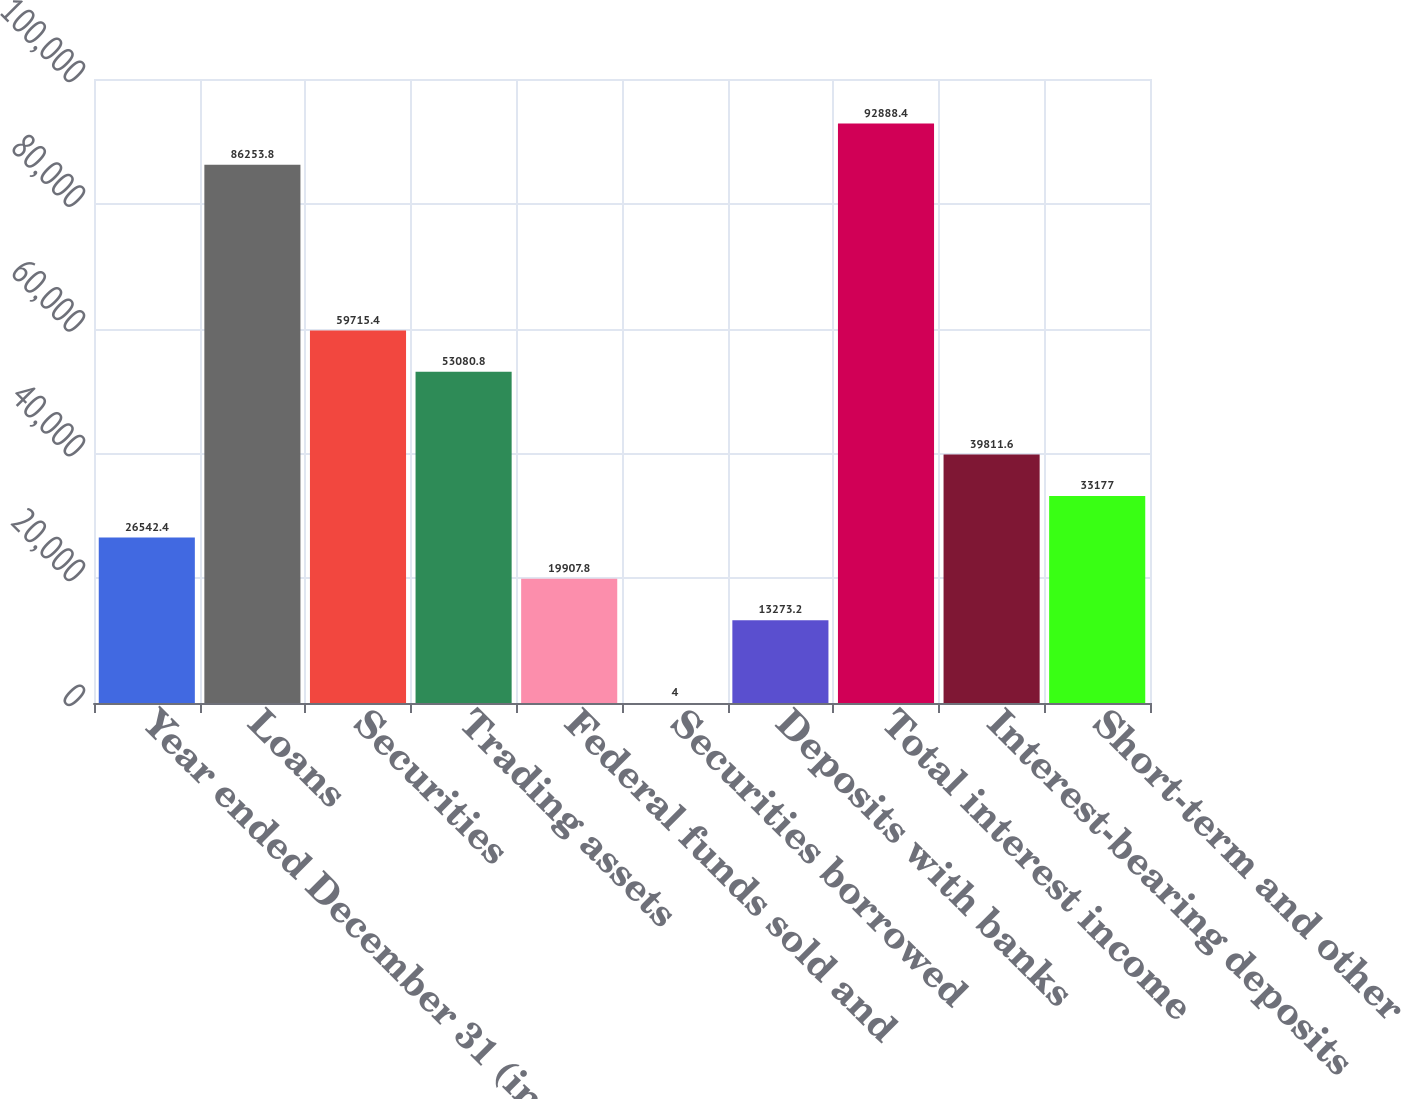Convert chart. <chart><loc_0><loc_0><loc_500><loc_500><bar_chart><fcel>Year ended December 31 (in<fcel>Loans<fcel>Securities<fcel>Trading assets<fcel>Federal funds sold and<fcel>Securities borrowed<fcel>Deposits with banks<fcel>Total interest income<fcel>Interest-bearing deposits<fcel>Short-term and other<nl><fcel>26542.4<fcel>86253.8<fcel>59715.4<fcel>53080.8<fcel>19907.8<fcel>4<fcel>13273.2<fcel>92888.4<fcel>39811.6<fcel>33177<nl></chart> 